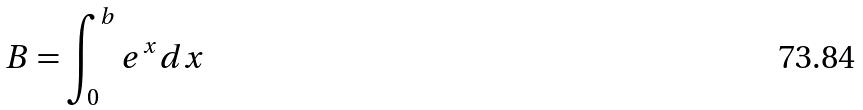Convert formula to latex. <formula><loc_0><loc_0><loc_500><loc_500>B = \int _ { 0 } ^ { b } e ^ { x } d x</formula> 